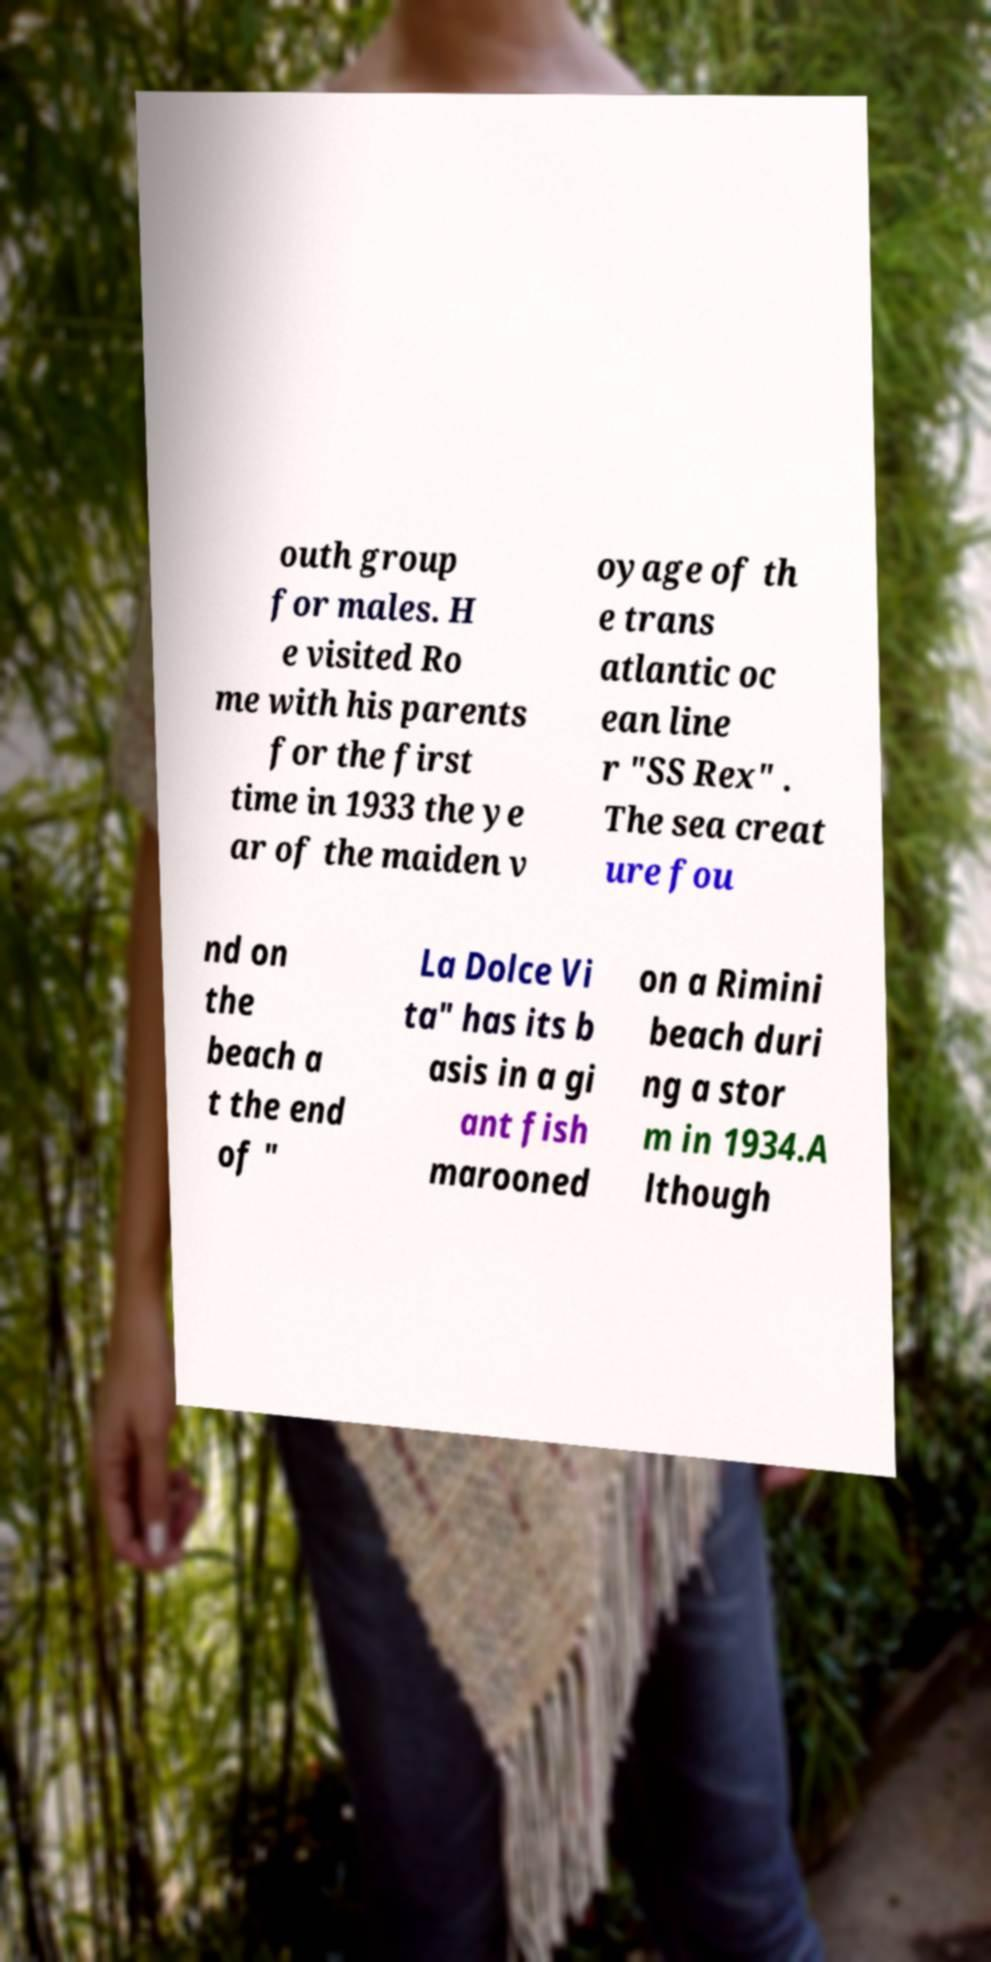Can you accurately transcribe the text from the provided image for me? outh group for males. H e visited Ro me with his parents for the first time in 1933 the ye ar of the maiden v oyage of th e trans atlantic oc ean line r "SS Rex" . The sea creat ure fou nd on the beach a t the end of " La Dolce Vi ta" has its b asis in a gi ant fish marooned on a Rimini beach duri ng a stor m in 1934.A lthough 